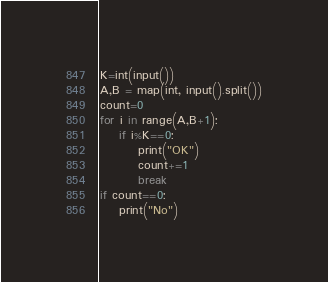<code> <loc_0><loc_0><loc_500><loc_500><_Python_>K=int(input())
A,B = map(int, input().split())
count=0
for i in range(A,B+1):
    if i%K==0:
        print("OK")
        count+=1
        break
if count==0:
    print("No")</code> 